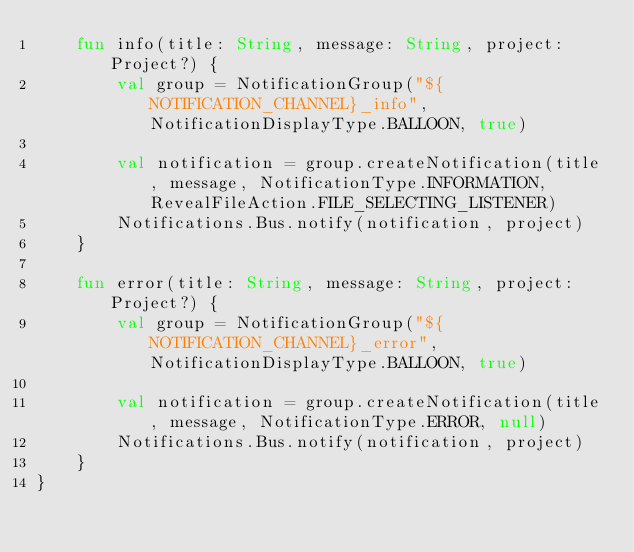Convert code to text. <code><loc_0><loc_0><loc_500><loc_500><_Kotlin_>    fun info(title: String, message: String, project: Project?) {
        val group = NotificationGroup("${NOTIFICATION_CHANNEL}_info", NotificationDisplayType.BALLOON, true)

        val notification = group.createNotification(title, message, NotificationType.INFORMATION, RevealFileAction.FILE_SELECTING_LISTENER)
        Notifications.Bus.notify(notification, project)
    }

    fun error(title: String, message: String, project: Project?) {
        val group = NotificationGroup("${NOTIFICATION_CHANNEL}_error", NotificationDisplayType.BALLOON, true)

        val notification = group.createNotification(title, message, NotificationType.ERROR, null)
        Notifications.Bus.notify(notification, project)
    }
}</code> 